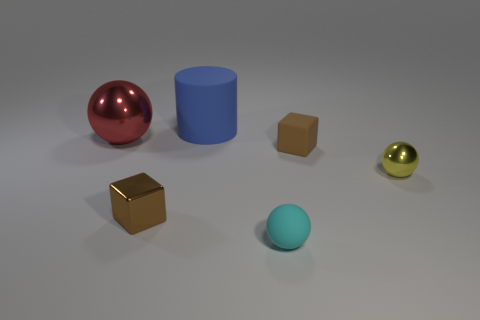Subtract all green balls. Subtract all cyan cylinders. How many balls are left? 3 Add 3 big red metallic spheres. How many objects exist? 9 Subtract all cylinders. How many objects are left? 5 Subtract all blue objects. Subtract all brown metallic objects. How many objects are left? 4 Add 3 blue matte cylinders. How many blue matte cylinders are left? 4 Add 4 cyan balls. How many cyan balls exist? 5 Subtract 1 yellow spheres. How many objects are left? 5 